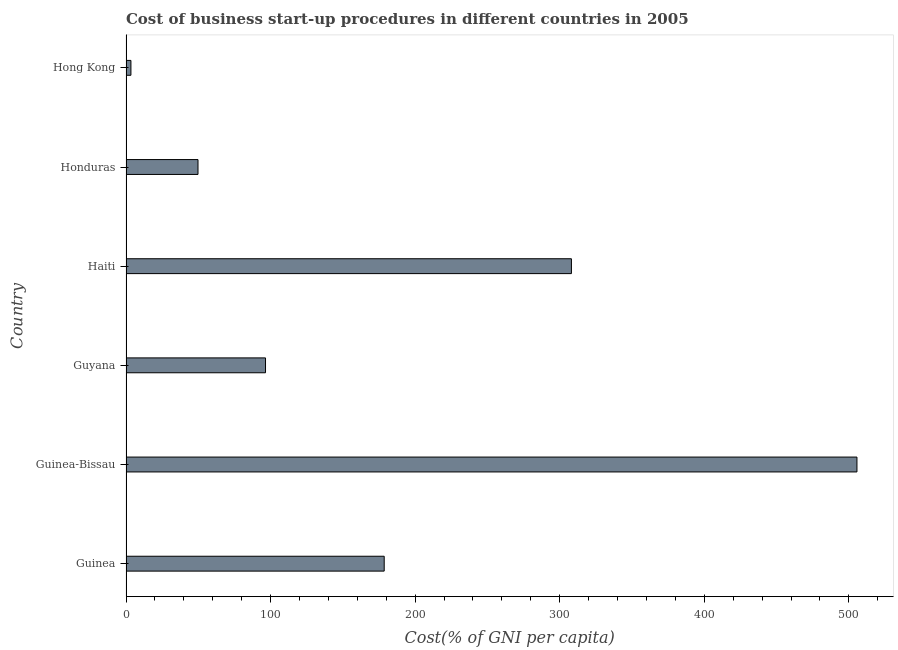What is the title of the graph?
Your answer should be very brief. Cost of business start-up procedures in different countries in 2005. What is the label or title of the X-axis?
Provide a succinct answer. Cost(% of GNI per capita). What is the label or title of the Y-axis?
Provide a short and direct response. Country. What is the cost of business startup procedures in Honduras?
Your answer should be very brief. 49.8. Across all countries, what is the maximum cost of business startup procedures?
Make the answer very short. 505.6. Across all countries, what is the minimum cost of business startup procedures?
Make the answer very short. 3.4. In which country was the cost of business startup procedures maximum?
Give a very brief answer. Guinea-Bissau. In which country was the cost of business startup procedures minimum?
Offer a terse response. Hong Kong. What is the sum of the cost of business startup procedures?
Your answer should be compact. 1142. What is the difference between the cost of business startup procedures in Guinea-Bissau and Honduras?
Your answer should be very brief. 455.8. What is the average cost of business startup procedures per country?
Give a very brief answer. 190.33. What is the median cost of business startup procedures?
Ensure brevity in your answer.  137.55. What is the ratio of the cost of business startup procedures in Haiti to that in Honduras?
Your answer should be very brief. 6.19. Is the cost of business startup procedures in Guyana less than that in Honduras?
Make the answer very short. No. What is the difference between the highest and the second highest cost of business startup procedures?
Offer a very short reply. 197.5. Is the sum of the cost of business startup procedures in Guinea-Bissau and Haiti greater than the maximum cost of business startup procedures across all countries?
Your answer should be very brief. Yes. What is the difference between the highest and the lowest cost of business startup procedures?
Provide a succinct answer. 502.2. In how many countries, is the cost of business startup procedures greater than the average cost of business startup procedures taken over all countries?
Ensure brevity in your answer.  2. How many bars are there?
Provide a succinct answer. 6. Are all the bars in the graph horizontal?
Give a very brief answer. Yes. What is the difference between two consecutive major ticks on the X-axis?
Offer a very short reply. 100. What is the Cost(% of GNI per capita) of Guinea?
Make the answer very short. 178.6. What is the Cost(% of GNI per capita) in Guinea-Bissau?
Your response must be concise. 505.6. What is the Cost(% of GNI per capita) of Guyana?
Your answer should be compact. 96.5. What is the Cost(% of GNI per capita) in Haiti?
Keep it short and to the point. 308.1. What is the Cost(% of GNI per capita) in Honduras?
Your answer should be very brief. 49.8. What is the difference between the Cost(% of GNI per capita) in Guinea and Guinea-Bissau?
Keep it short and to the point. -327. What is the difference between the Cost(% of GNI per capita) in Guinea and Guyana?
Provide a succinct answer. 82.1. What is the difference between the Cost(% of GNI per capita) in Guinea and Haiti?
Provide a short and direct response. -129.5. What is the difference between the Cost(% of GNI per capita) in Guinea and Honduras?
Provide a succinct answer. 128.8. What is the difference between the Cost(% of GNI per capita) in Guinea and Hong Kong?
Your answer should be compact. 175.2. What is the difference between the Cost(% of GNI per capita) in Guinea-Bissau and Guyana?
Ensure brevity in your answer.  409.1. What is the difference between the Cost(% of GNI per capita) in Guinea-Bissau and Haiti?
Make the answer very short. 197.5. What is the difference between the Cost(% of GNI per capita) in Guinea-Bissau and Honduras?
Provide a succinct answer. 455.8. What is the difference between the Cost(% of GNI per capita) in Guinea-Bissau and Hong Kong?
Provide a succinct answer. 502.2. What is the difference between the Cost(% of GNI per capita) in Guyana and Haiti?
Ensure brevity in your answer.  -211.6. What is the difference between the Cost(% of GNI per capita) in Guyana and Honduras?
Provide a short and direct response. 46.7. What is the difference between the Cost(% of GNI per capita) in Guyana and Hong Kong?
Provide a succinct answer. 93.1. What is the difference between the Cost(% of GNI per capita) in Haiti and Honduras?
Offer a terse response. 258.3. What is the difference between the Cost(% of GNI per capita) in Haiti and Hong Kong?
Offer a very short reply. 304.7. What is the difference between the Cost(% of GNI per capita) in Honduras and Hong Kong?
Offer a terse response. 46.4. What is the ratio of the Cost(% of GNI per capita) in Guinea to that in Guinea-Bissau?
Provide a succinct answer. 0.35. What is the ratio of the Cost(% of GNI per capita) in Guinea to that in Guyana?
Make the answer very short. 1.85. What is the ratio of the Cost(% of GNI per capita) in Guinea to that in Haiti?
Make the answer very short. 0.58. What is the ratio of the Cost(% of GNI per capita) in Guinea to that in Honduras?
Give a very brief answer. 3.59. What is the ratio of the Cost(% of GNI per capita) in Guinea to that in Hong Kong?
Your answer should be compact. 52.53. What is the ratio of the Cost(% of GNI per capita) in Guinea-Bissau to that in Guyana?
Provide a succinct answer. 5.24. What is the ratio of the Cost(% of GNI per capita) in Guinea-Bissau to that in Haiti?
Offer a very short reply. 1.64. What is the ratio of the Cost(% of GNI per capita) in Guinea-Bissau to that in Honduras?
Offer a very short reply. 10.15. What is the ratio of the Cost(% of GNI per capita) in Guinea-Bissau to that in Hong Kong?
Offer a very short reply. 148.71. What is the ratio of the Cost(% of GNI per capita) in Guyana to that in Haiti?
Keep it short and to the point. 0.31. What is the ratio of the Cost(% of GNI per capita) in Guyana to that in Honduras?
Offer a terse response. 1.94. What is the ratio of the Cost(% of GNI per capita) in Guyana to that in Hong Kong?
Ensure brevity in your answer.  28.38. What is the ratio of the Cost(% of GNI per capita) in Haiti to that in Honduras?
Offer a very short reply. 6.19. What is the ratio of the Cost(% of GNI per capita) in Haiti to that in Hong Kong?
Provide a short and direct response. 90.62. What is the ratio of the Cost(% of GNI per capita) in Honduras to that in Hong Kong?
Ensure brevity in your answer.  14.65. 